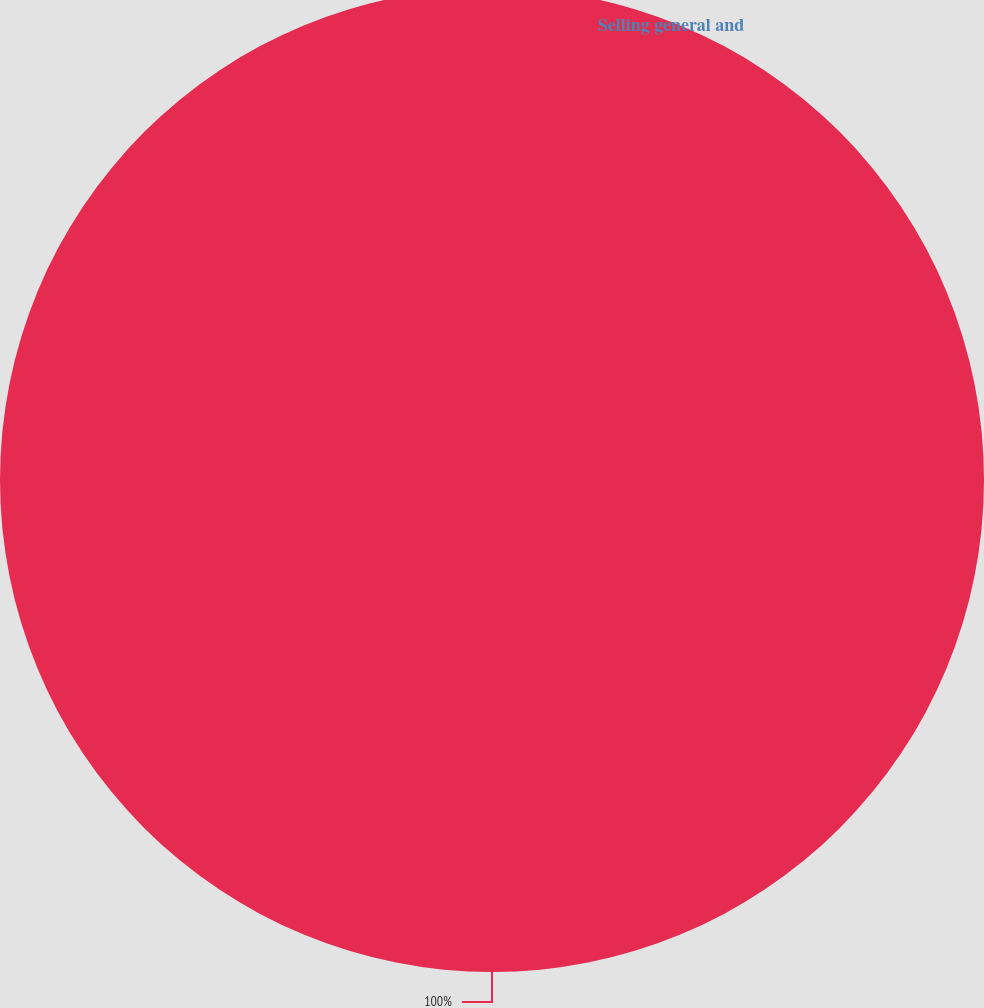<chart> <loc_0><loc_0><loc_500><loc_500><pie_chart><fcel>Selling general and<nl><fcel>100.0%<nl></chart> 